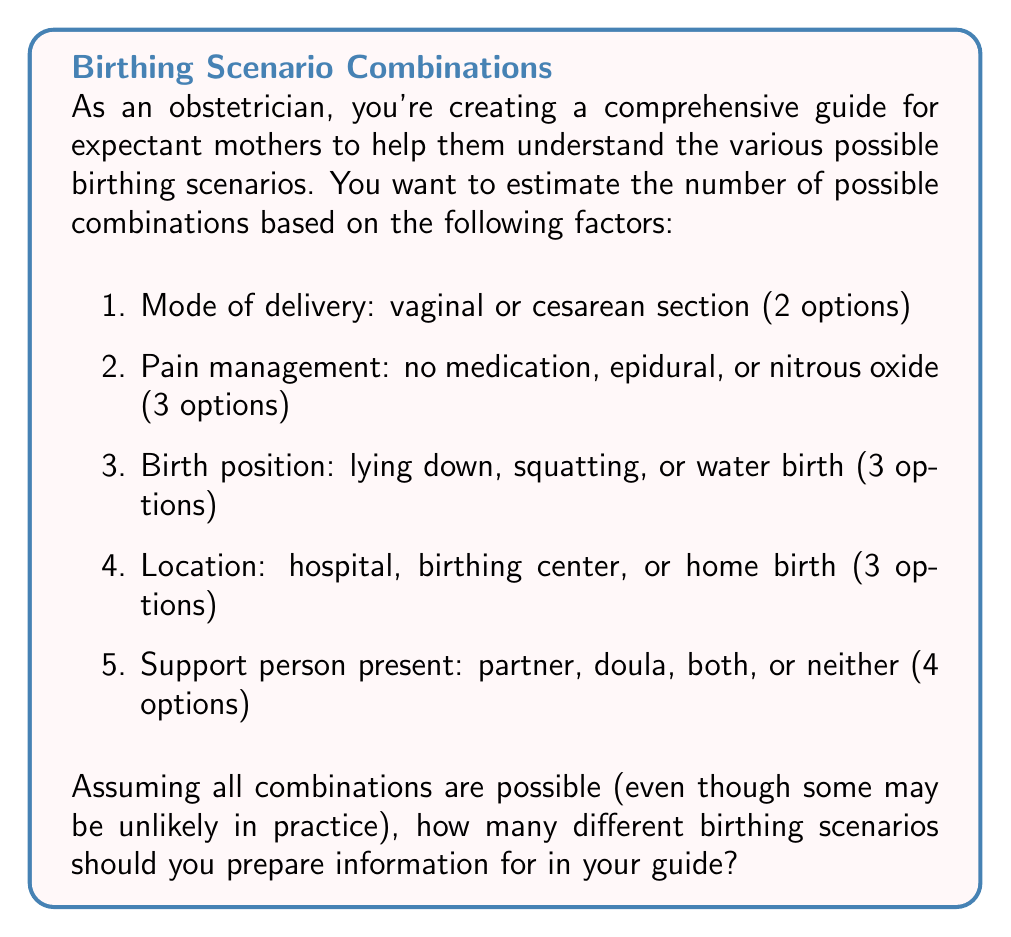Teach me how to tackle this problem. To solve this problem, we'll use the multiplication principle of counting. This principle states that if we have a series of independent choices, the total number of possible outcomes is the product of the number of options for each choice.

Let's break down the problem step by step:

1. Mode of delivery: 2 options
2. Pain management: 3 options
3. Birth position: 3 options
4. Location: 3 options
5. Support person present: 4 options

Using the multiplication principle, we multiply the number of options for each factor:

$$ \text{Total scenarios} = 2 \times 3 \times 3 \times 3 \times 4 $$

Calculating this:

$$ \begin{aligned}
\text{Total scenarios} &= 2 \times 3 \times 3 \times 3 \times 4 \\
&= 6 \times 3 \times 3 \times 4 \\
&= 18 \times 3 \times 4 \\
&= 54 \times 4 \\
&= 216
\end{aligned} $$

Therefore, there are 216 possible birthing scenarios based on the given factors.

It's important to note that while this calculation gives us the mathematical total of possible combinations, not all of these scenarios may be medically advisable or common in practice. As an obstetrician sensitive to patients' stigma and guilt, you would likely want to focus on the most common and safest options while acknowledging that each birth experience is unique.
Answer: 216 possible birthing scenarios 